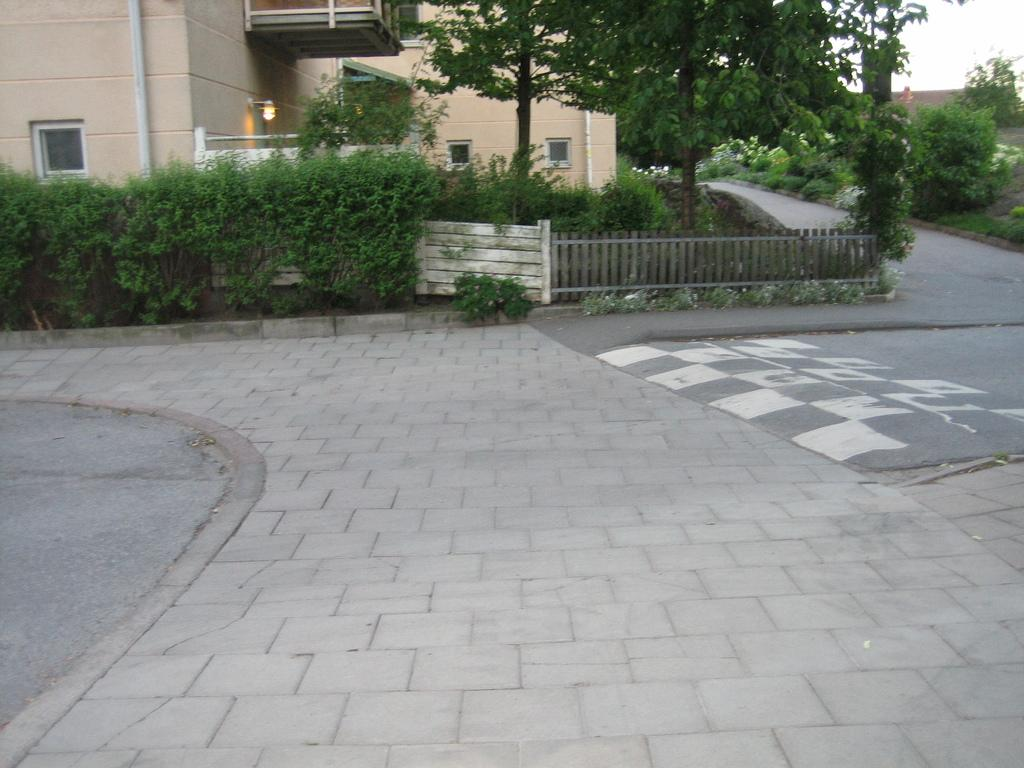Where was the image taken? The image was taken beside a road. What can be seen at the bottom of the image? There are trees, a fence, plants, a building, and tiles at the bottom of the image. What is the texture of the sneeze in the image? There is no sneeze present in the image, so it is not possible to determine its texture. 